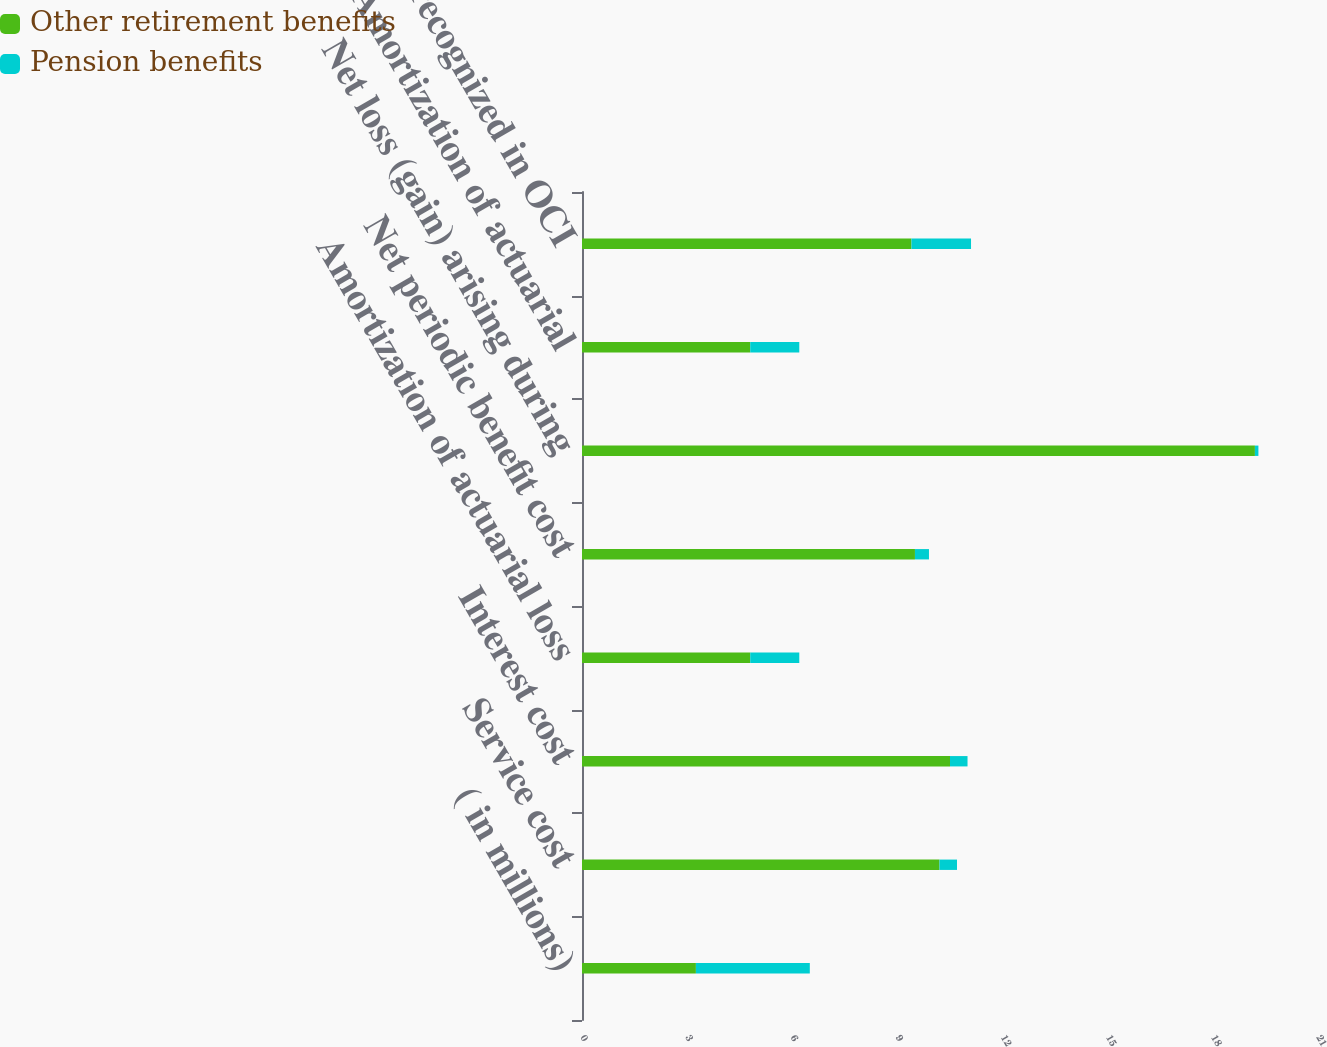Convert chart. <chart><loc_0><loc_0><loc_500><loc_500><stacked_bar_chart><ecel><fcel>( in millions)<fcel>Service cost<fcel>Interest cost<fcel>Amortization of actuarial loss<fcel>Net periodic benefit cost<fcel>Net loss (gain) arising during<fcel>Amortization of actuarial<fcel>Total recognized in OCI<nl><fcel>Other retirement benefits<fcel>3.25<fcel>10.2<fcel>10.5<fcel>4.8<fcel>9.5<fcel>19.2<fcel>4.8<fcel>9.4<nl><fcel>Pension benefits<fcel>3.25<fcel>0.5<fcel>0.5<fcel>1.4<fcel>0.4<fcel>0.1<fcel>1.4<fcel>1.7<nl></chart> 